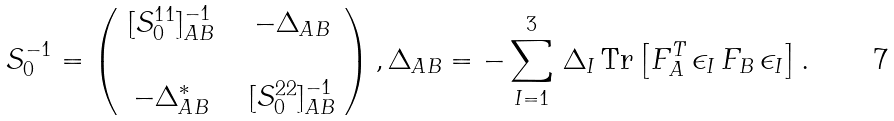Convert formula to latex. <formula><loc_0><loc_0><loc_500><loc_500>S _ { 0 } ^ { - 1 } = \left ( \begin{array} { c c c } [ S _ { 0 } ^ { 1 1 } ] _ { A B } ^ { - 1 } & & - \Delta _ { A B } \\ & & \\ - \Delta _ { A B } ^ { * } & & [ S _ { 0 } ^ { 2 2 } ] _ { A B } ^ { - 1 } \end{array} \right ) , \Delta _ { A B } = - \sum _ { I = 1 } ^ { 3 } \, \Delta _ { I } \, \text {Tr} \left [ F _ { A } ^ { T } \, \epsilon _ { I } \, F _ { B } \, \epsilon _ { I } \right ] .</formula> 